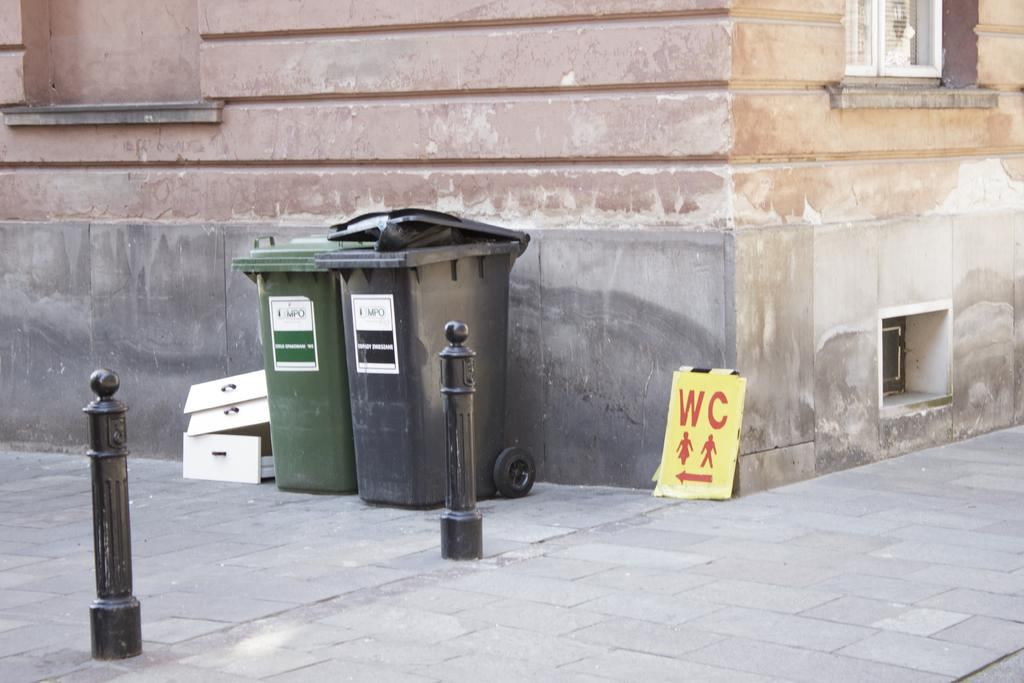Provide a one-sentence caption for the provided image. Garbage bins outdoors next to a sign which says WC. 